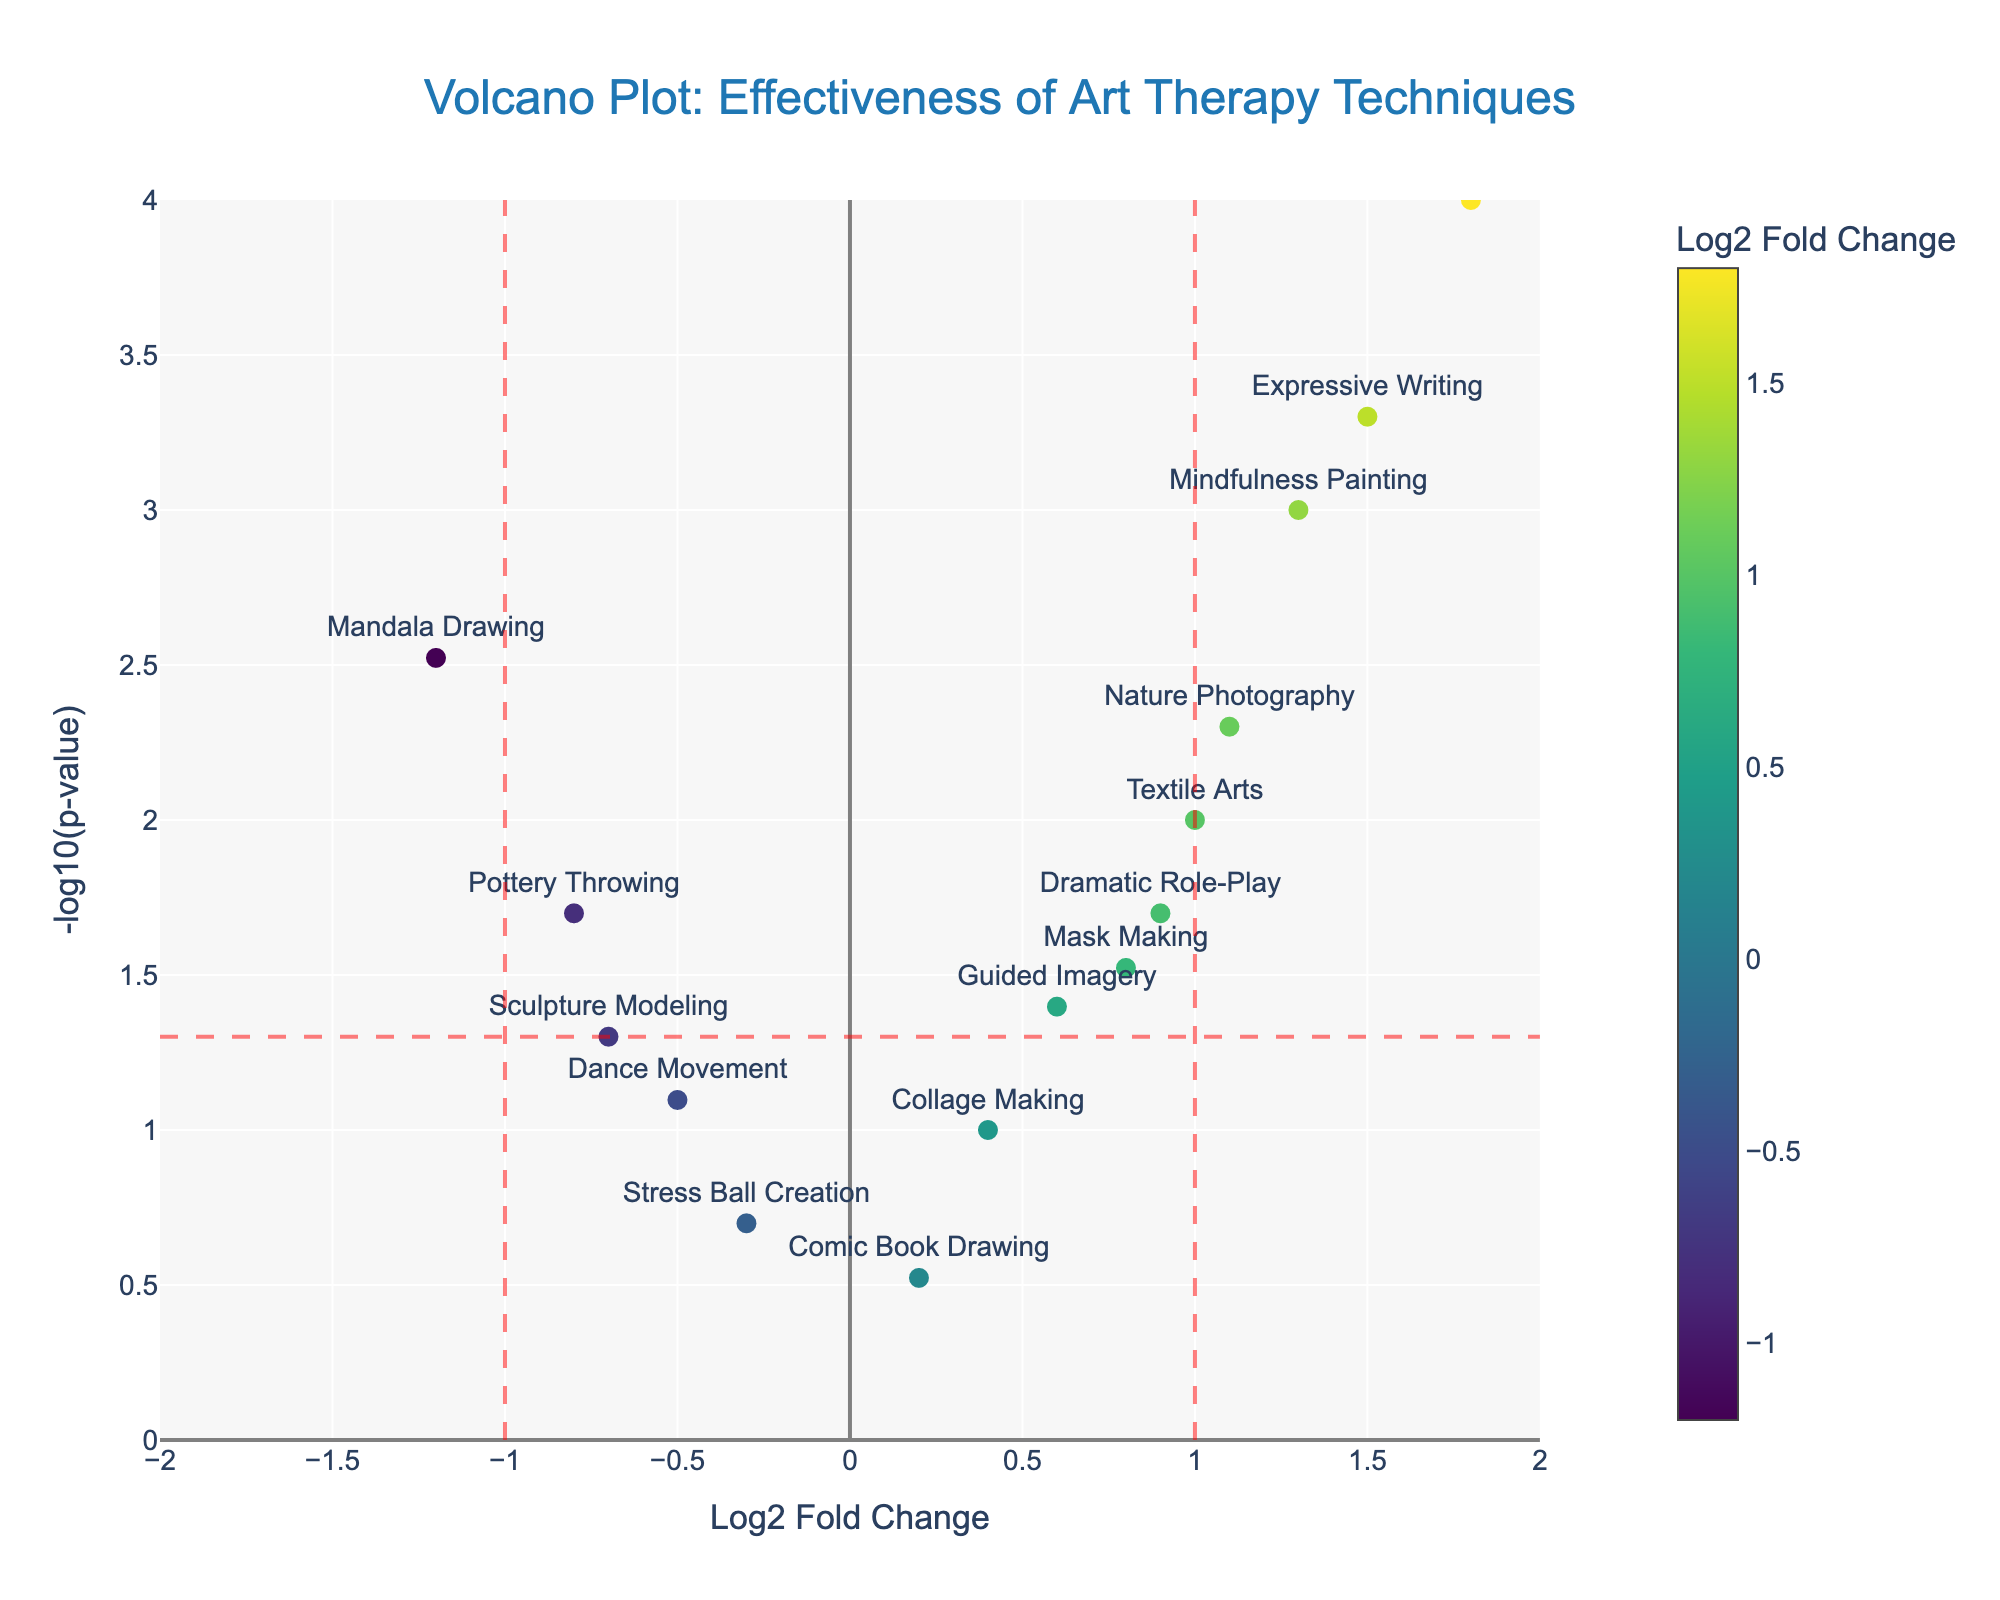What is the title of the figure? The title of the figure is shown at the top in a larger font and states the purpose of the plot.
Answer: "Volcano Plot: Effectiveness of Art Therapy Techniques" Which therapy technique shows the highest Log2 fold change? To find the technique with the highest Log2 fold change, look for the highest x-coordinate value.
Answer: Music Creation How many techniques have a Log2 fold change greater than 1? Look at the right side of the vertical threshold line at x = 1 and count the data points.
Answer: 4 Which technique has the smallest p-value? The technique with the smallest p-value will have the highest y-coordinate value.
Answer: Music Creation Are there any techniques that show a negative Log2 fold change and have a p-value less than 0.05? Look in the lower-left quadrant of the plot, considering the vertical line at x = -1 and the horizontal line at y = -log10(0.05).
Answer: Mandala Drawing, Sculpture Modeling, Pottery Throwing Which technique shows a Log2 fold change of 1.3 and what is its p-value? Locate the technique at the x-coordinate 1.3 on the plot, and look at its y-coordinate for the p-value.
Answer: Mindfulness Painting, 0.001 How does Expressive Writing compare to Mandala Drawing in terms of Log2 fold change and p-value? Compare the x and y-coordinates of Expressive Writing and Mandala Drawing on the plot.
Answer: Expressive Writing has a higher Log2 fold change (1.5 vs. -1.2) and a lower p-value (0.0005 vs. 0.003) What is the significance threshold for the p-value shown in the plot? The significance threshold is denoted by a horizontal line, typically at a standard threshold value.
Answer: 0.05 Which technique shows the second highest Log2 fold change and what is its p-value? Identify the second highest x-coordinate value and find the corresponding y-coordinate.
Answer: Expressive Writing, 0.0005 